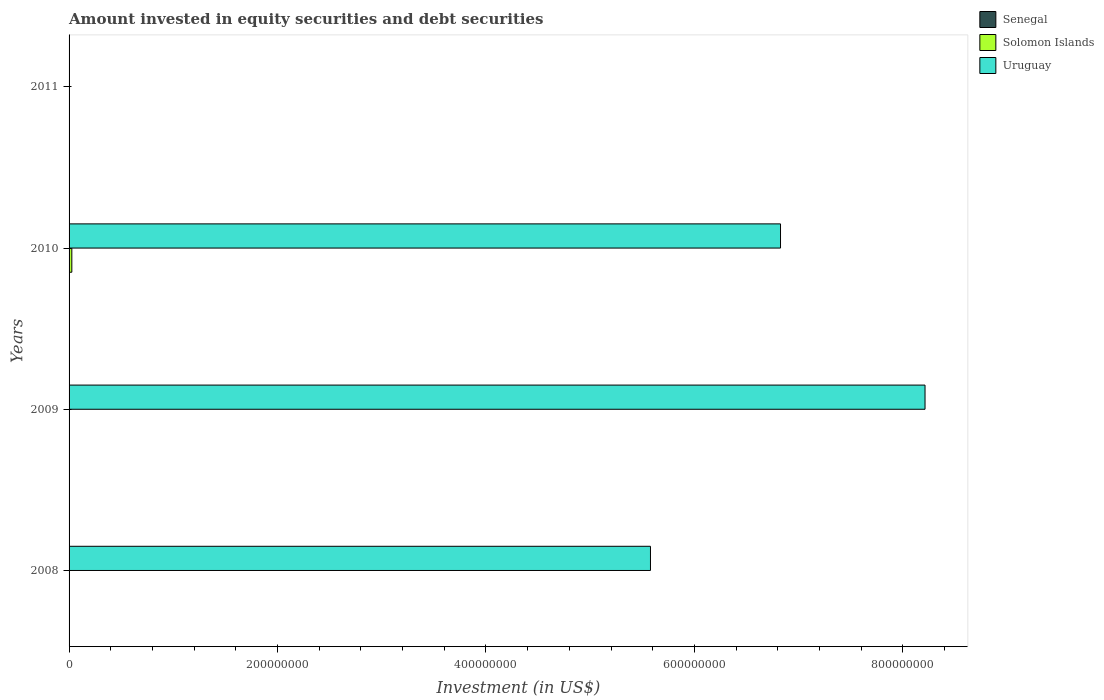How many bars are there on the 1st tick from the top?
Offer a very short reply. 0. What is the amount invested in equity securities and debt securities in Uruguay in 2011?
Ensure brevity in your answer.  0. Across all years, what is the maximum amount invested in equity securities and debt securities in Solomon Islands?
Provide a succinct answer. 2.65e+06. Across all years, what is the minimum amount invested in equity securities and debt securities in Solomon Islands?
Your answer should be compact. 0. What is the total amount invested in equity securities and debt securities in Senegal in the graph?
Your response must be concise. 0. What is the difference between the amount invested in equity securities and debt securities in Senegal in 2009 and the amount invested in equity securities and debt securities in Solomon Islands in 2011?
Offer a terse response. 0. In how many years, is the amount invested in equity securities and debt securities in Senegal greater than 400000000 US$?
Keep it short and to the point. 0. What is the ratio of the amount invested in equity securities and debt securities in Uruguay in 2009 to that in 2010?
Make the answer very short. 1.2. What is the difference between the highest and the second highest amount invested in equity securities and debt securities in Uruguay?
Provide a short and direct response. 1.39e+08. What is the difference between the highest and the lowest amount invested in equity securities and debt securities in Uruguay?
Keep it short and to the point. 8.21e+08. Is the sum of the amount invested in equity securities and debt securities in Uruguay in 2009 and 2010 greater than the maximum amount invested in equity securities and debt securities in Senegal across all years?
Offer a terse response. Yes. Are all the bars in the graph horizontal?
Give a very brief answer. Yes. How many years are there in the graph?
Make the answer very short. 4. What is the difference between two consecutive major ticks on the X-axis?
Make the answer very short. 2.00e+08. Are the values on the major ticks of X-axis written in scientific E-notation?
Offer a very short reply. No. How are the legend labels stacked?
Your answer should be very brief. Vertical. What is the title of the graph?
Offer a terse response. Amount invested in equity securities and debt securities. What is the label or title of the X-axis?
Your answer should be very brief. Investment (in US$). What is the Investment (in US$) of Uruguay in 2008?
Keep it short and to the point. 5.58e+08. What is the Investment (in US$) in Uruguay in 2009?
Ensure brevity in your answer.  8.21e+08. What is the Investment (in US$) of Solomon Islands in 2010?
Ensure brevity in your answer.  2.65e+06. What is the Investment (in US$) of Uruguay in 2010?
Provide a short and direct response. 6.83e+08. What is the Investment (in US$) of Solomon Islands in 2011?
Your response must be concise. 0. What is the Investment (in US$) of Uruguay in 2011?
Give a very brief answer. 0. Across all years, what is the maximum Investment (in US$) of Solomon Islands?
Give a very brief answer. 2.65e+06. Across all years, what is the maximum Investment (in US$) of Uruguay?
Keep it short and to the point. 8.21e+08. Across all years, what is the minimum Investment (in US$) in Solomon Islands?
Your answer should be very brief. 0. Across all years, what is the minimum Investment (in US$) in Uruguay?
Give a very brief answer. 0. What is the total Investment (in US$) of Solomon Islands in the graph?
Your answer should be very brief. 2.65e+06. What is the total Investment (in US$) in Uruguay in the graph?
Your answer should be very brief. 2.06e+09. What is the difference between the Investment (in US$) in Uruguay in 2008 and that in 2009?
Your response must be concise. -2.63e+08. What is the difference between the Investment (in US$) of Uruguay in 2008 and that in 2010?
Your answer should be very brief. -1.25e+08. What is the difference between the Investment (in US$) in Uruguay in 2009 and that in 2010?
Make the answer very short. 1.39e+08. What is the average Investment (in US$) of Solomon Islands per year?
Keep it short and to the point. 6.62e+05. What is the average Investment (in US$) in Uruguay per year?
Keep it short and to the point. 5.15e+08. In the year 2010, what is the difference between the Investment (in US$) in Solomon Islands and Investment (in US$) in Uruguay?
Make the answer very short. -6.80e+08. What is the ratio of the Investment (in US$) of Uruguay in 2008 to that in 2009?
Make the answer very short. 0.68. What is the ratio of the Investment (in US$) of Uruguay in 2008 to that in 2010?
Provide a short and direct response. 0.82. What is the ratio of the Investment (in US$) in Uruguay in 2009 to that in 2010?
Keep it short and to the point. 1.2. What is the difference between the highest and the second highest Investment (in US$) of Uruguay?
Your answer should be very brief. 1.39e+08. What is the difference between the highest and the lowest Investment (in US$) of Solomon Islands?
Provide a short and direct response. 2.65e+06. What is the difference between the highest and the lowest Investment (in US$) of Uruguay?
Ensure brevity in your answer.  8.21e+08. 